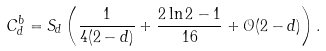<formula> <loc_0><loc_0><loc_500><loc_500>C _ { d } ^ { b } = S _ { d } \left ( \frac { 1 } { 4 ( 2 - d ) } + \frac { 2 \ln 2 - 1 } { 1 6 } + \mathcal { O } ( 2 - d ) \right ) .</formula> 